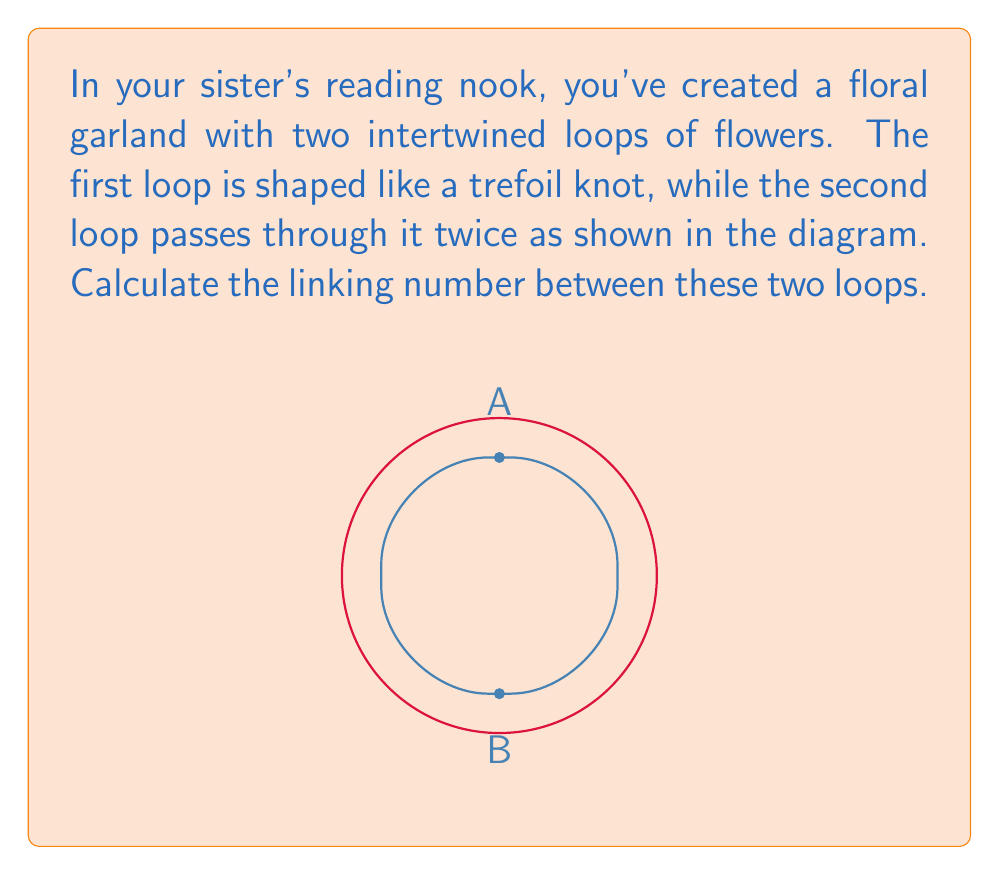Can you answer this question? To compute the linking number between the two loops in the floral garland, we'll follow these steps:

1) The linking number is calculated as half the sum of the signed crossings between the two loops.

2) In this diagram, we need to count the crossings where the blue loop (second loop) passes under or over the red loop (trefoil knot).

3) We assign +1 to crossings where the blue loop passes under the red loop (from the perspective of the arrow on the red loop), and -1 where it passes over.

4) Starting from point A and moving to point B along the blue loop:
   - First crossing: Blue passes under Red, +1
   - Second crossing: Blue passes under Red, +1

5) Moving from B back to A to complete the blue loop:
   - Third crossing: Blue passes under Red, +1
   - Fourth crossing: Blue passes under Red, +1

6) Sum of signed crossings: $(+1) + (+1) + (+1) + (+1) = 4$

7) The linking number is half of this sum: $\frac{4}{2} = 2$

Therefore, the linking number between the two loops in the floral garland is 2.
Answer: 2 